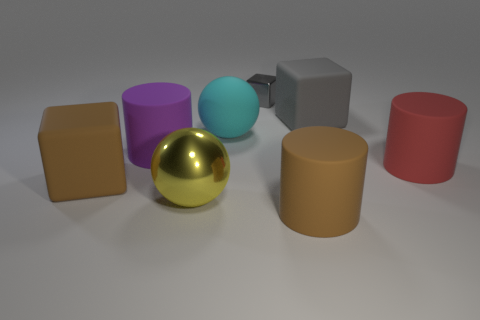Add 2 yellow metal objects. How many objects exist? 10 Subtract all cylinders. How many objects are left? 5 Add 3 large cubes. How many large cubes exist? 5 Subtract 1 red cylinders. How many objects are left? 7 Subtract all rubber balls. Subtract all cyan rubber spheres. How many objects are left? 6 Add 4 big cyan rubber spheres. How many big cyan rubber spheres are left? 5 